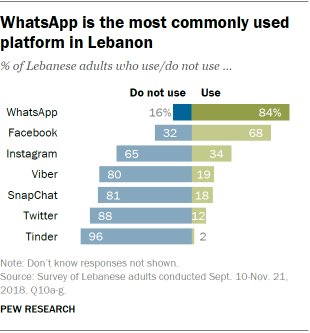Mention a couple of crucial points in this snapshot. The majority of people use two apps. According to recent surveys, WhatsApp is used by 84% of people. 